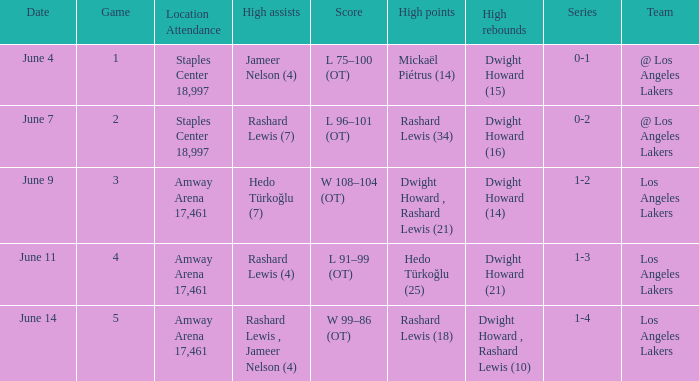What is Series, when Date is "June 7"? 0-2. 